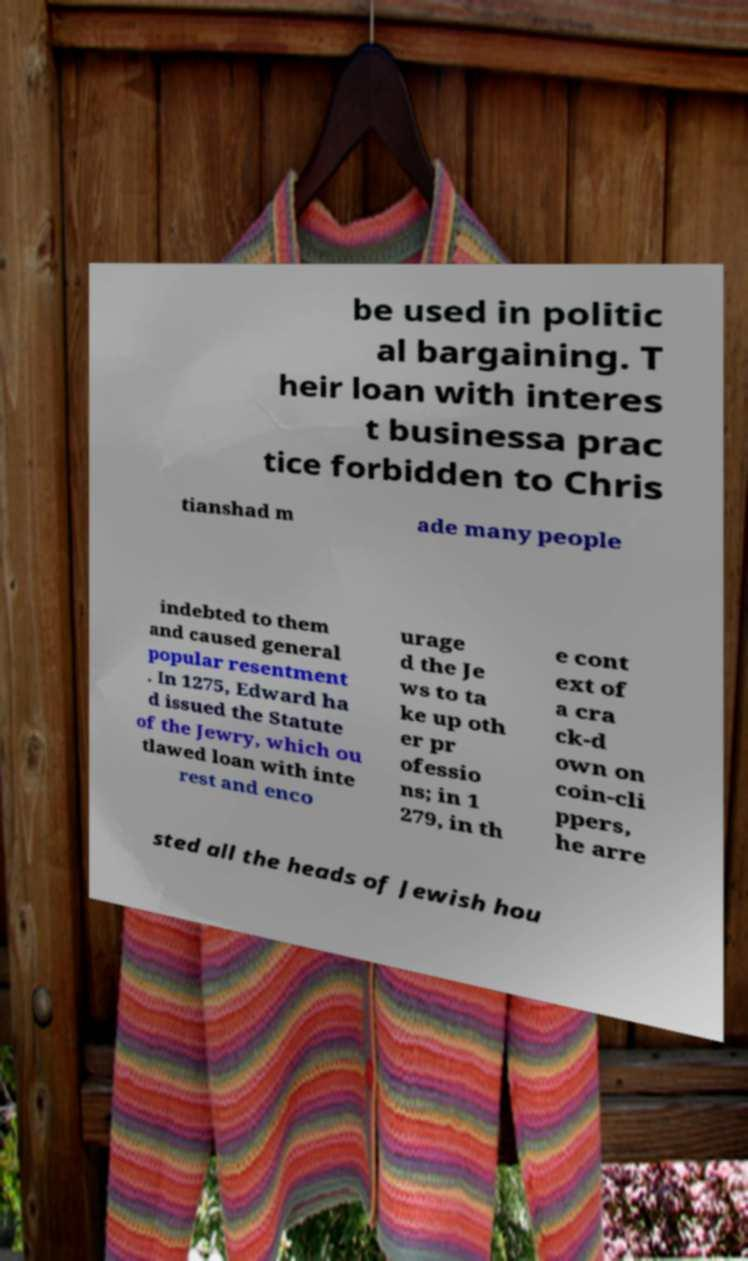What messages or text are displayed in this image? I need them in a readable, typed format. be used in politic al bargaining. T heir loan with interes t businessa prac tice forbidden to Chris tianshad m ade many people indebted to them and caused general popular resentment . In 1275, Edward ha d issued the Statute of the Jewry, which ou tlawed loan with inte rest and enco urage d the Je ws to ta ke up oth er pr ofessio ns; in 1 279, in th e cont ext of a cra ck-d own on coin-cli ppers, he arre sted all the heads of Jewish hou 